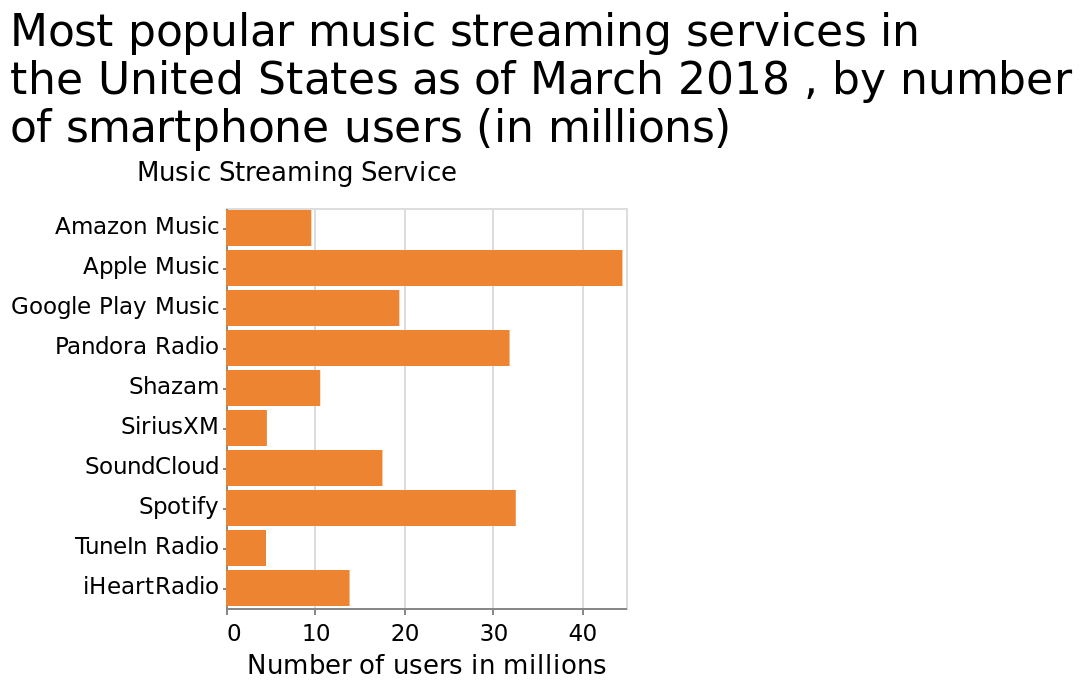<image>
What is the title of the bar graph?  The title of the bar graph is "Most popular music streaming services in the United States as of March 2018, by number of smartphone users (in millions)." What was the most popular music streaming service in the United States as of March 2018? Apple Music. 